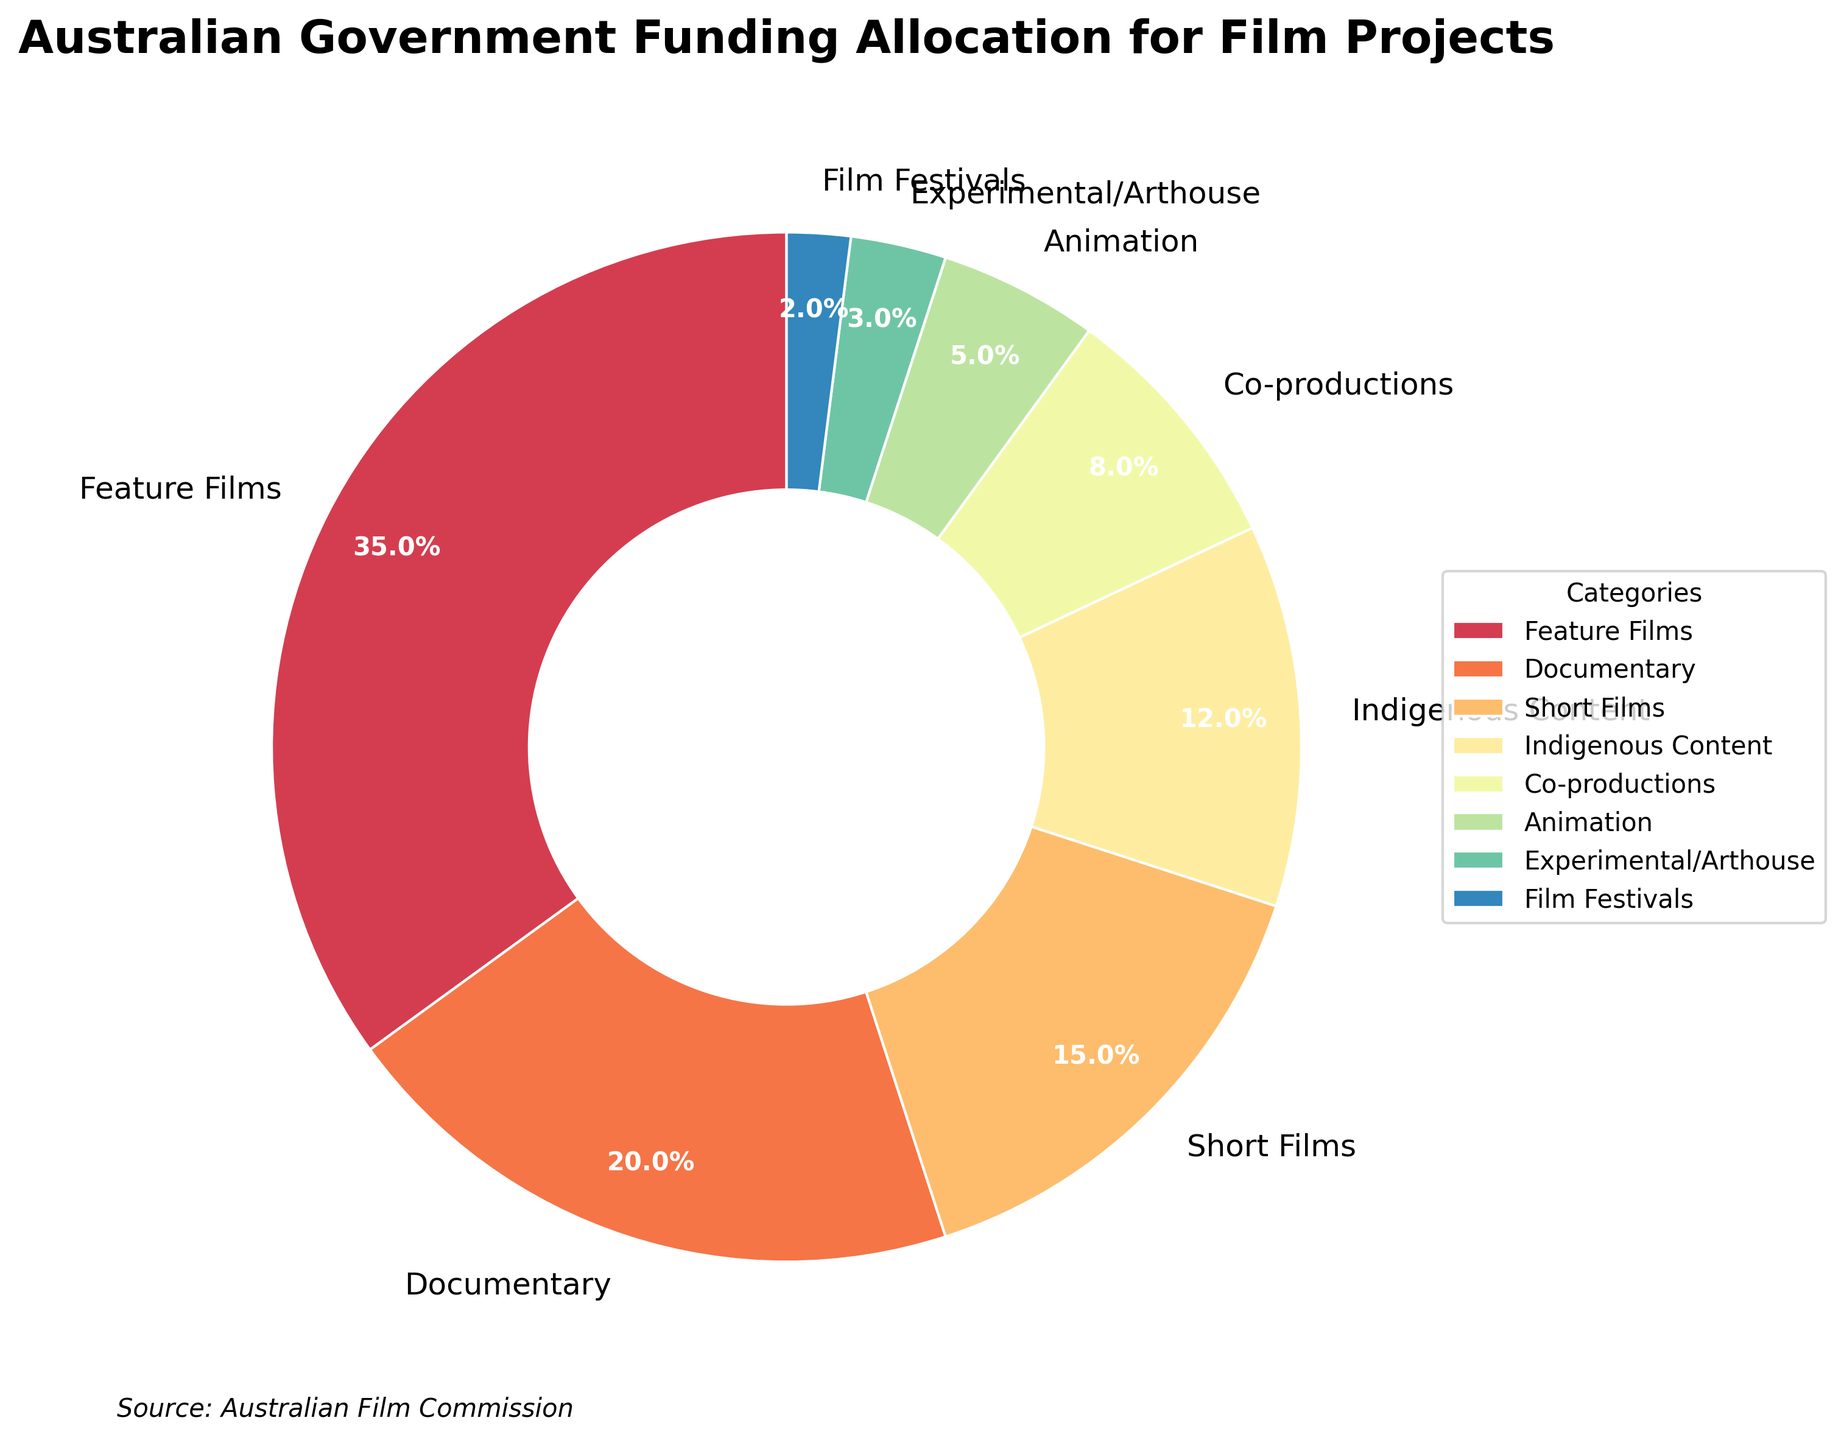Which category receives the highest percentage of funding? The figure shows that 'Feature Films' have the largest segment of the pie chart.
Answer: Feature Films What is the combined funding allocation for Short Films and Indigenous Content? The figure shows that Short Films receive 15% and Indigenous Content receives 12%. Adding them together: 15% + 12% = 27%.
Answer: 27% How much more funding is allocated to Feature Films than to Documentaries? The figure shows that Feature Films receive 35% of the funding and Documentaries receive 20%. Subtracting these values: 35% - 20% = 15%.
Answer: 15% Which category has the smallest percentage of funding, and what is that percentage? The figure shows that 'Film Festivals' has the smallest segment in the pie chart, which is 2%.
Answer: Film Festivals, 2% Is funding for Animation greater than or less than funding for Co-productions? By how much? The figure shows Animation receives 5% of the funding, and Co-productions receive 8%. Since 8% is greater than 5%, the difference is 8% - 5% = 3%.
Answer: Less, 3% What is the total percentage of funding allocated to categories that receive less than 10% each? Adding the percentages for Indigenous Content (12%), Co-productions (8%), Animation (5%), Experimental/Arthouse (3%), and Film Festivals (2%): 12% + 8% + 5% + 3% + 2% = 30%.
Answer: 30% Between Documentary and Feature Films, which category receives more funding and by what percentage difference? The figure shows Feature Films receive 35% and Documentaries receive 20% of the funding. The difference is 35% - 20% = 15%.
Answer: Feature Films, 15% What percentage of funding is allocated to categories specifically related to cultural content (Indigenous Content and Co-productions)? The figure shows Indigenous Content receives 12% and Co-productions receive 8%. Adding them together gives: 12% + 8% = 20%.
Answer: 20% Is the allocation for Experimental/Arthouse films higher or lower than the allocation for Animation? By looking at the pie chart, Experimental/Arthouse films receive 3% while Animation receives 5%. So, 3% is less than 5%.
Answer: Lower What is the difference in funding percentage between the three categories receiving the highest funding? The three categories with the highest funding are Feature Films (35%), Documentary (20%), and Short Films (15%). The difference between the highest (Feature Films) and the third highest (Short Films) is 35% - 15% = 20%.
Answer: 20% 